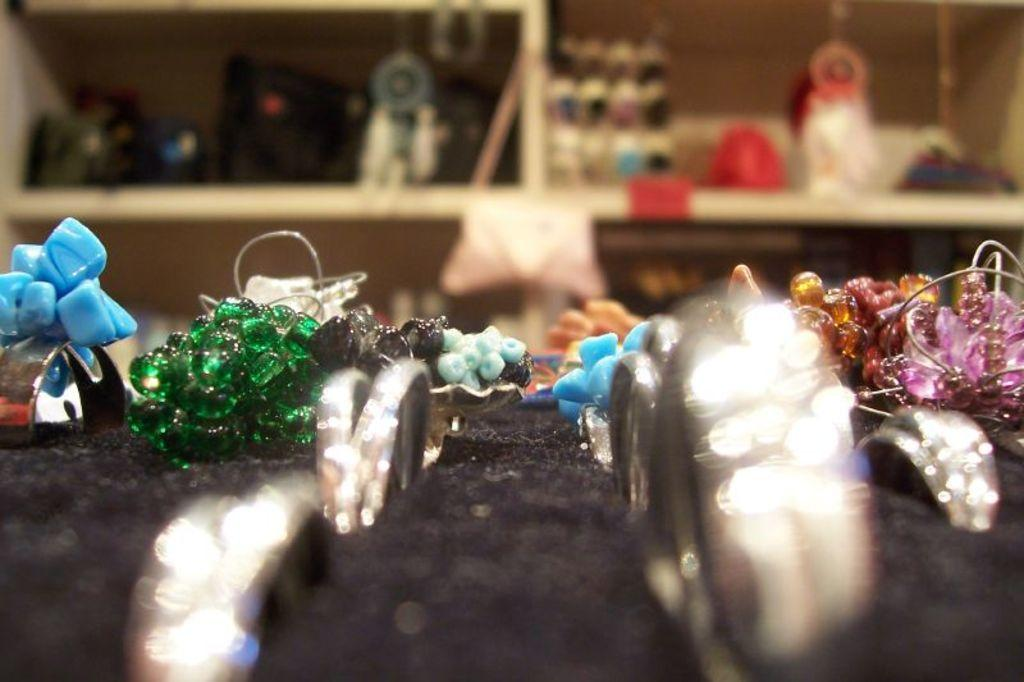What is the color of the object that has accessories on it? The object with accessories on it is black. What can be seen in the background of the image? There are items in the shelves in the background of the image. What type of action is the quince performing in the image? There is no quince present in the image, so it cannot perform any actions. 